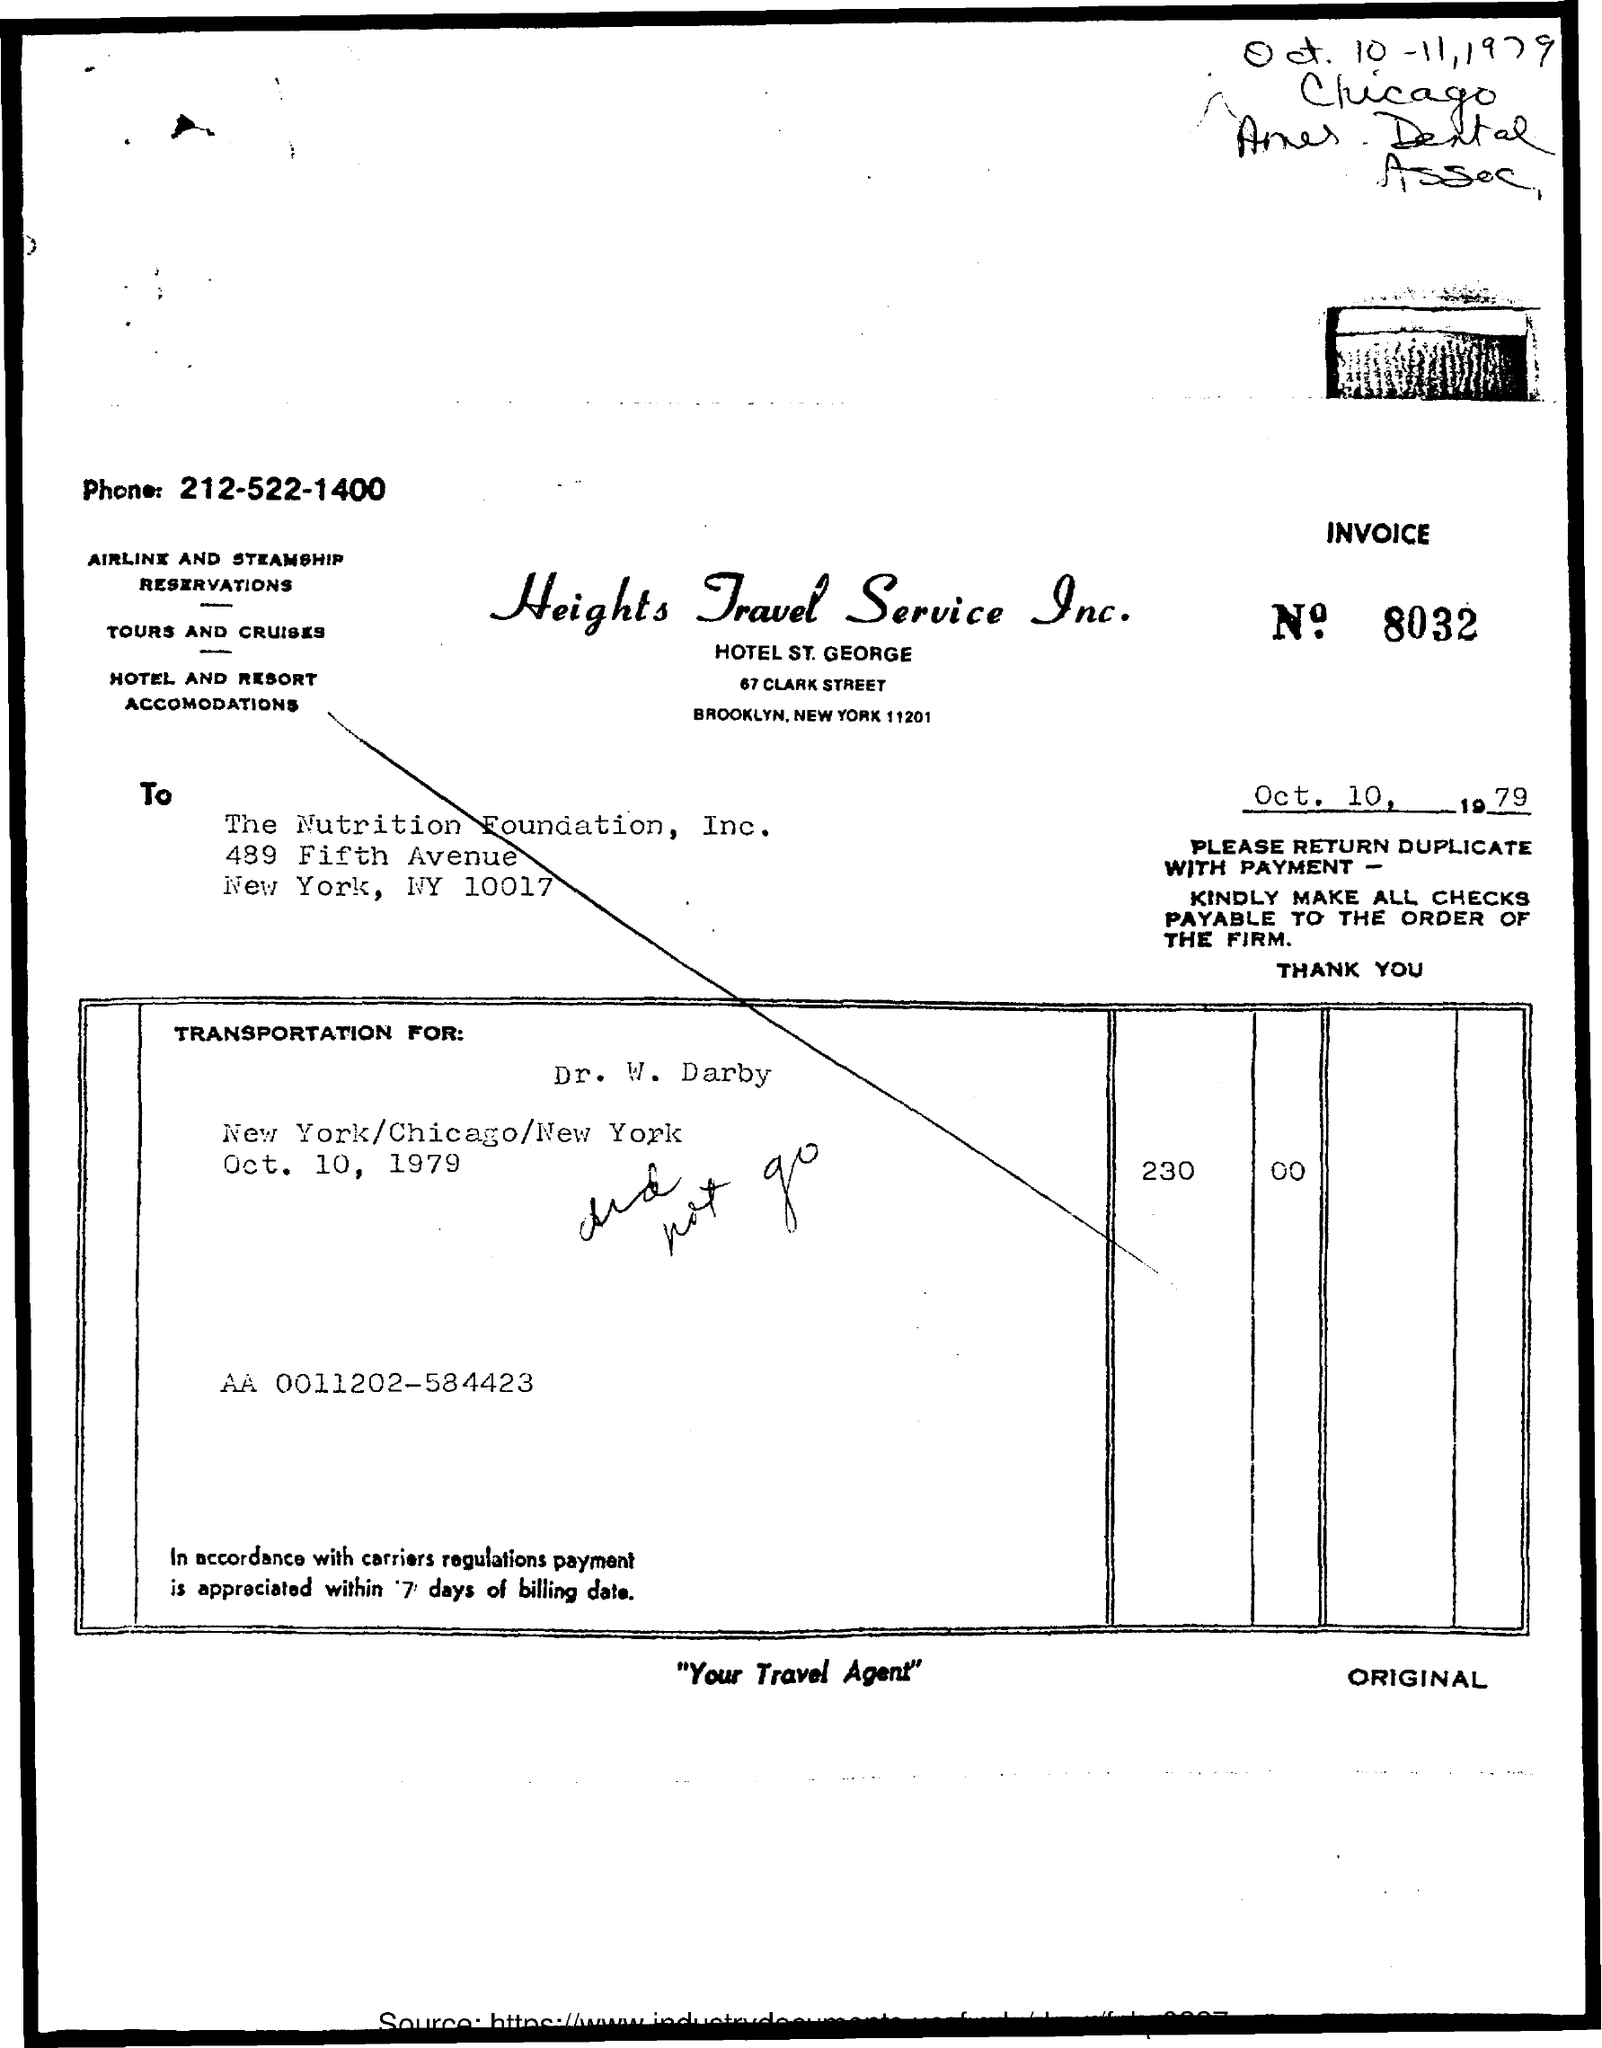What is the Invoice No. given in the document?
Ensure brevity in your answer.  8032. What is the issued date of the invoice?
Your response must be concise. Oct. 10, 1979. Which company has issued this invoice?
Provide a succinct answer. Heights Travel Service Inc. In which company's name, the invoice is issued?
Make the answer very short. The Nutrition Foundation, Inc. What is the Phone no of Heights Travel Service Inc.?
Your response must be concise. 212-522-1400. 